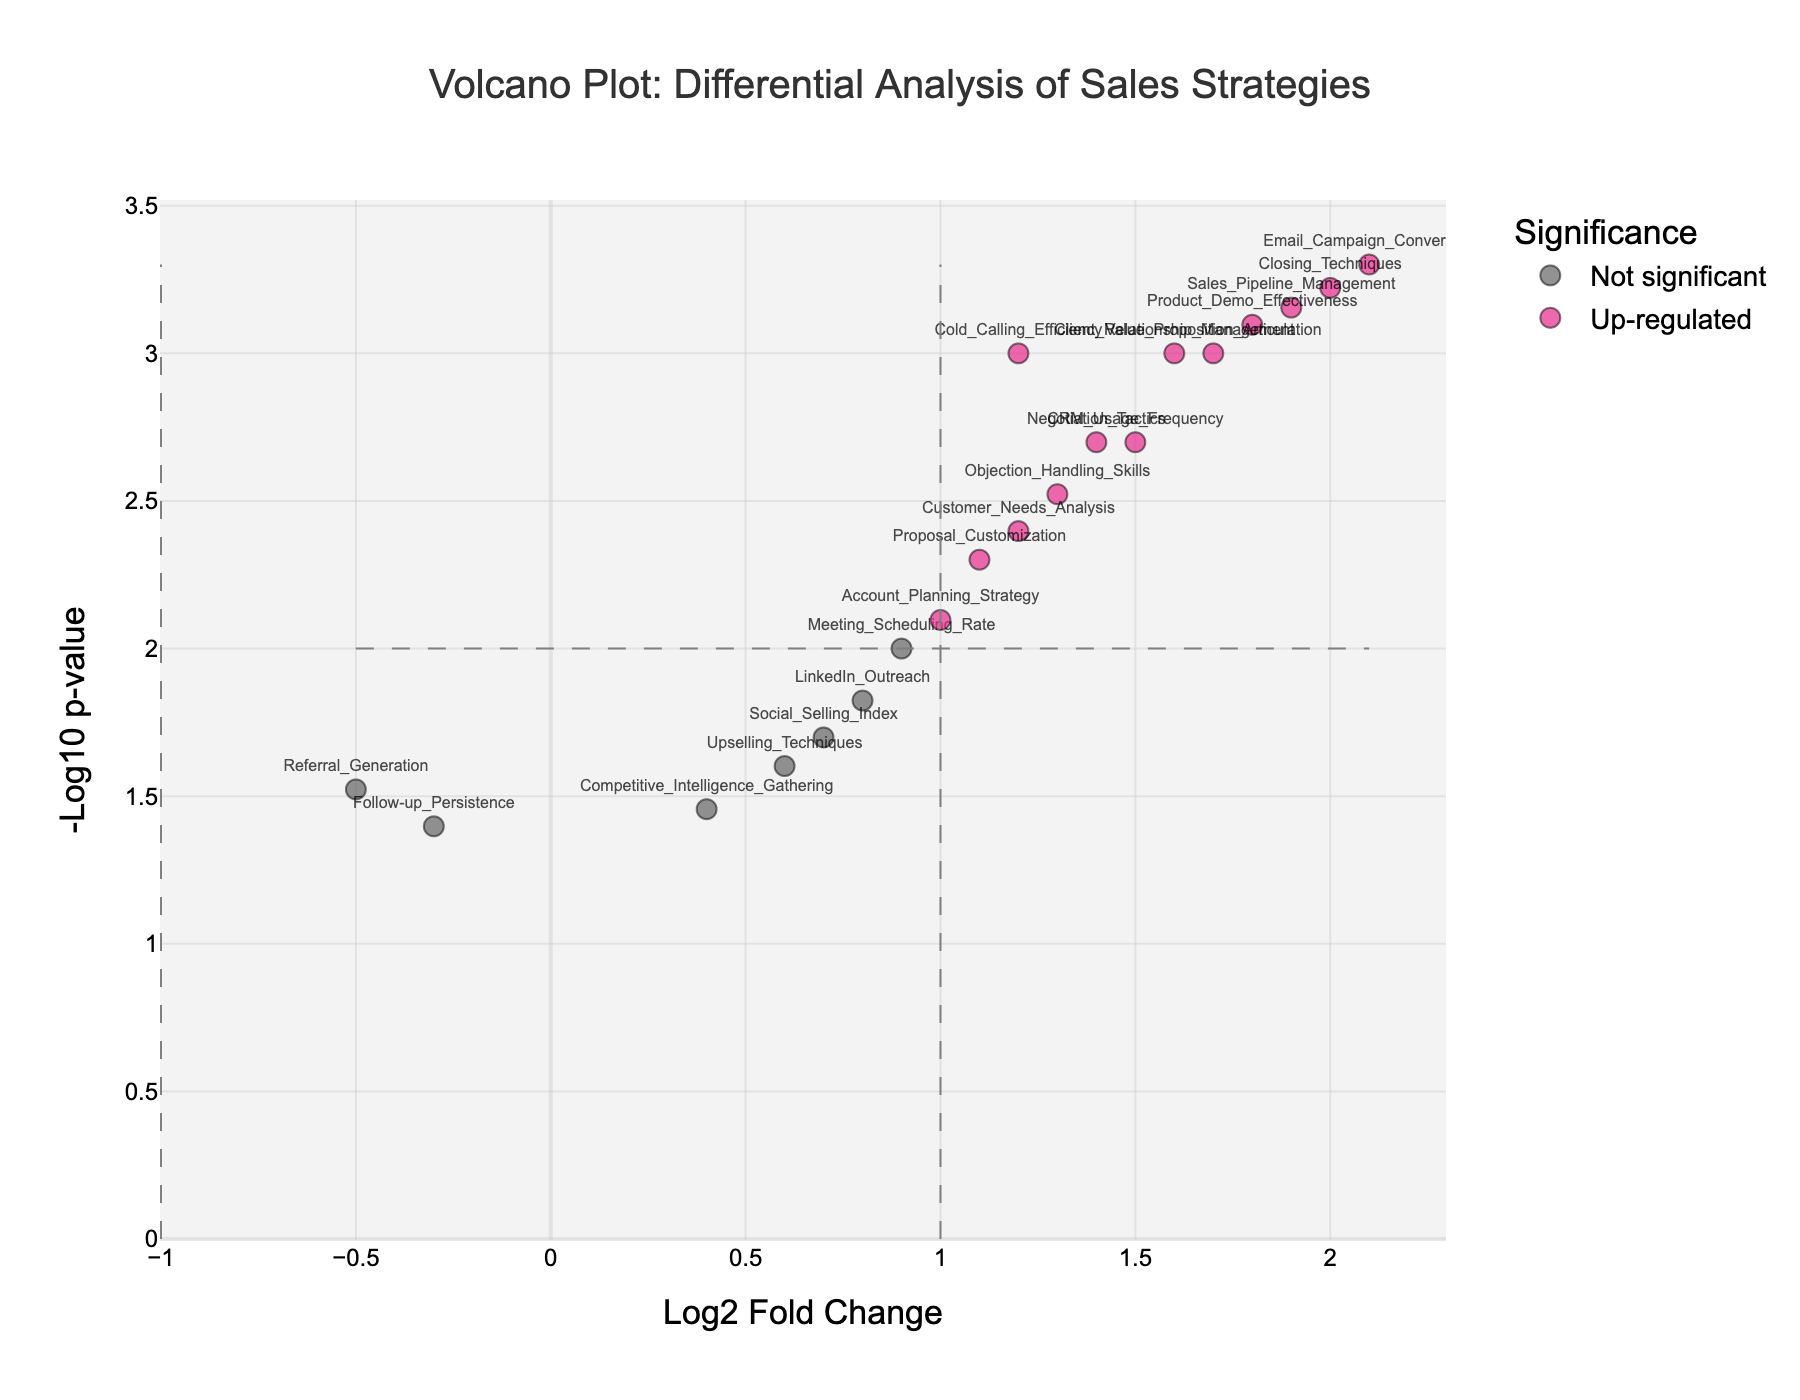How many data points are labeled as "Up-regulated"? The "Up-regulated" data points are represented by the color close to pink and lie in the region where the Log2 Fold Change (Log2FC) is greater than or equal to 1 and -Log10 p-value is greater than or equal to 2. The total number of these points is determined by counting the markers in this specific region.
Answer: 9 Which data point has the highest -Log10 p-value? To find the data point with the highest -Log10 p-value, we look for the marker that is plotted the highest on the Y-axis. This corresponds to the data point "Email_Campaign_Conversion".
Answer: Email_Campaign_Conversion What is the range of the Log2 Fold Change values shown on the X-axis? The range of Log2 Fold Change values is given by the minimum and maximum values on the X-axis. Based on the plot, the x-axis extends from -0.5 to 2.5.
Answer: -0.5 to 2.5 Which data points have been down-regulated? Down-regulated data points lie in the region where Log2FC is less than or equal to -1 and -Log10 p-value is greater than or equal to 2. These are marked in green. Inspecting the plot, we find there are no such data points that fit this criteria.
Answer: None How many data points have a p-value less than 0.01? To identify data points with p-value < 0.01, we look for markers with -Log10(p-value) greater than or equal to 2 on the Y-axis. Counting these markers from the plot, we find the total number to be 13 such points.
Answer: 13 Which data point has the highest Log2 Fold Change value? To find the data point with the highest Log2 Fold Change, we look for the marker that is plotted furthest to the right on the X-axis. This corresponds to which data point "Email_Campaign_Conversion".
Answer: Email_Campaign_Conversion What is the Log2 Fold Change value for "Meeting_Scheduling_Rate"? The Log2 Fold Change value for "Meeting_Scheduling_Rate" can be found by locating its marker on the X-axis, which is provided directly on the plot. The value is 0.9.
Answer: 0.9 Which data points show both high significance and high Log2 Fold Change? High significance is marked by a -Log10 p-value ≥ 2, and high Log2 Fold Change is defined as Log2FC ≥ 1. Data points in pink in the upper right quadrant of the plot satisfy this condition. These include "Cold_Calling_Efficiency", "Email_Campaign_Conversion", "CRM_Usage_Frequency", "Product_Demo_Effectiveness", "Objection_Handling_Skills", "Client_Relationship_Management", "Negotiation_Tactics", "Sales_Pipeline_Management", "Value_Proposition_Articulation", and "Closing_Techniques".
Answer: Cold_Calling_Efficiency, Email_Campaign_Conversion, CRM_Usage_Frequency, Product_Demo_Effectiveness, Objection_Handling_Skills, Client_Relationship_Management, Negotiation_Tactics, Sales_Pipeline_Management, Value_Proposition_Articulation, Closing_Techniques 